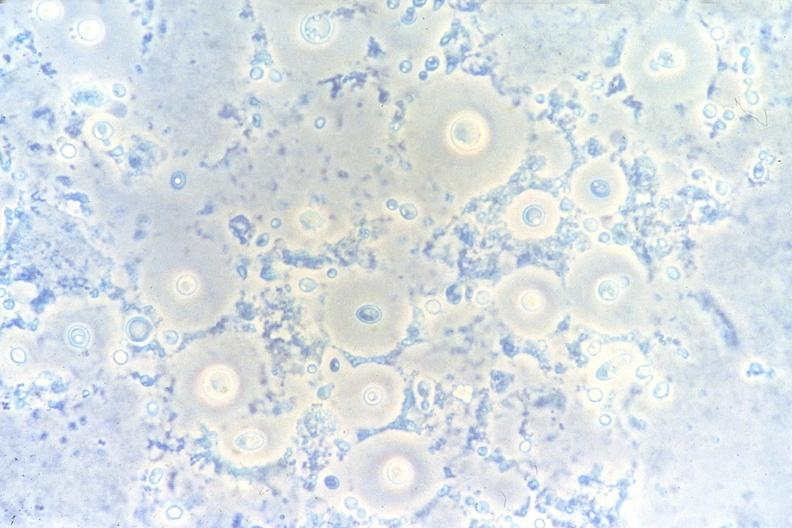what does this image show?
Answer the question using a single word or phrase. Lung 